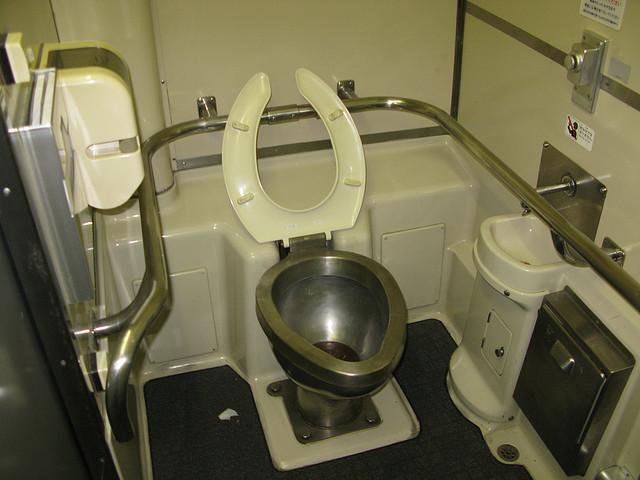What is the metal bin in the right corner?
Answer briefly. Trash. Is the toilet clean?
Quick response, please. Yes. Is this toilet located in a private home?
Write a very short answer. No. 